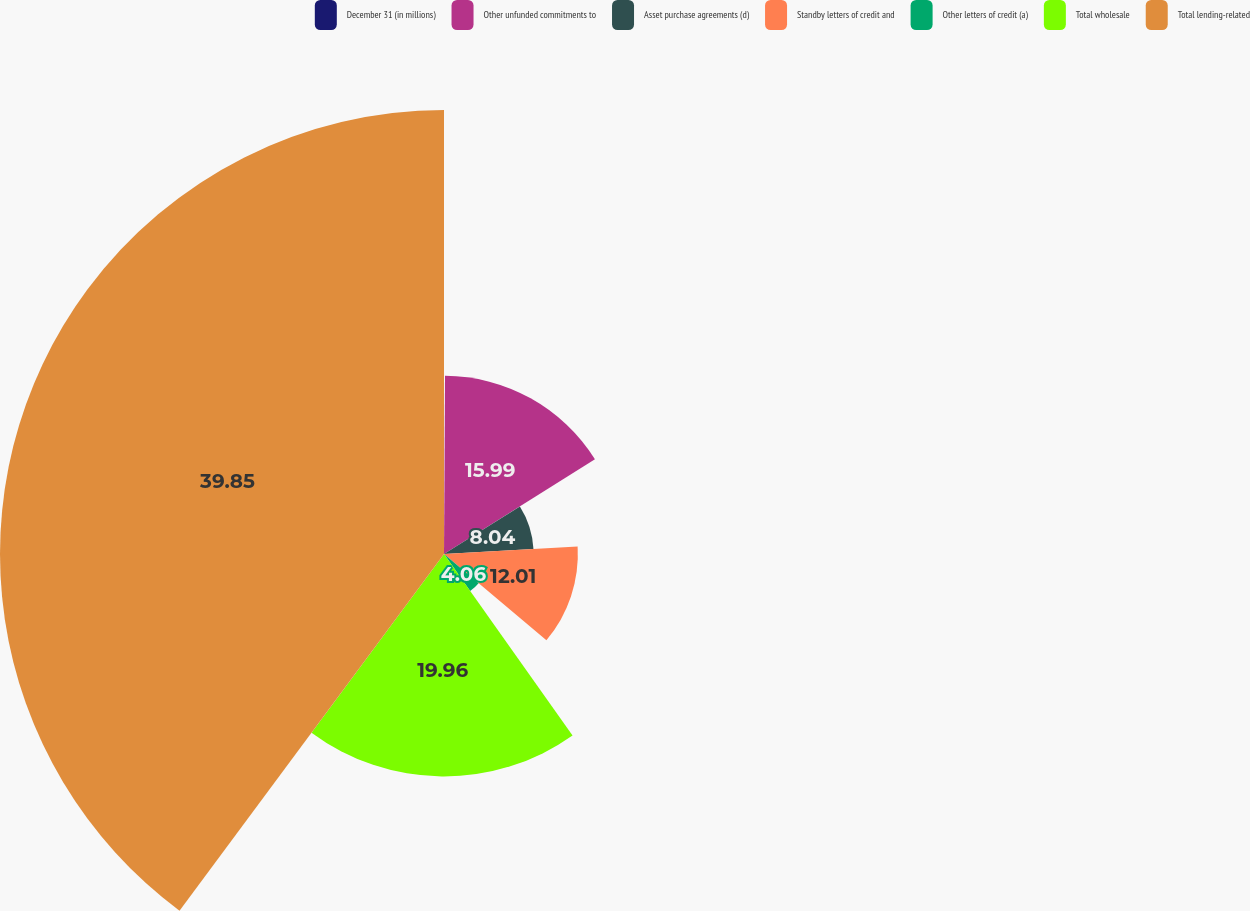Convert chart to OTSL. <chart><loc_0><loc_0><loc_500><loc_500><pie_chart><fcel>December 31 (in millions)<fcel>Other unfunded commitments to<fcel>Asset purchase agreements (d)<fcel>Standby letters of credit and<fcel>Other letters of credit (a)<fcel>Total wholesale<fcel>Total lending-related<nl><fcel>0.09%<fcel>15.99%<fcel>8.04%<fcel>12.01%<fcel>4.06%<fcel>19.96%<fcel>39.84%<nl></chart> 